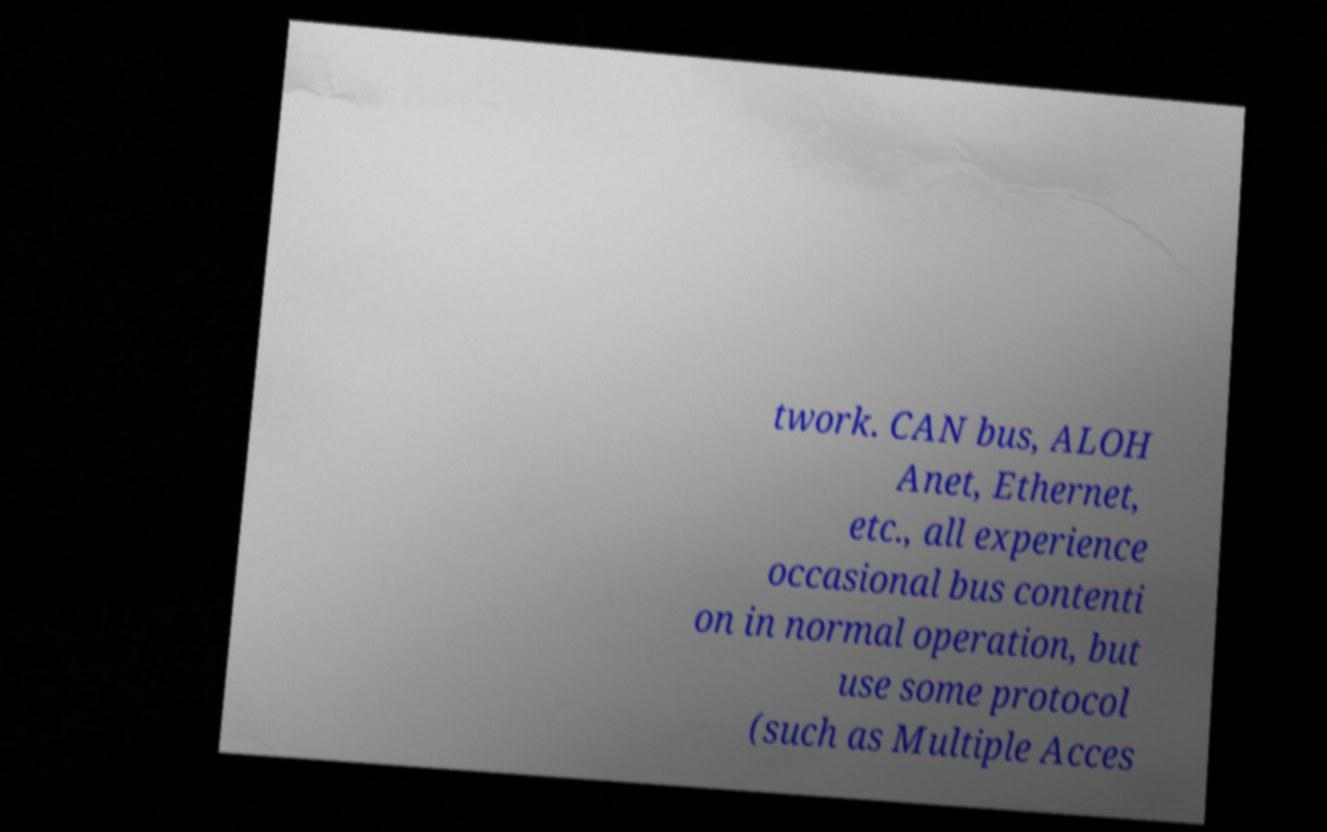Could you extract and type out the text from this image? twork. CAN bus, ALOH Anet, Ethernet, etc., all experience occasional bus contenti on in normal operation, but use some protocol (such as Multiple Acces 